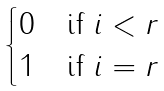<formula> <loc_0><loc_0><loc_500><loc_500>\begin{cases} 0 \quad \text {if } i < r \\ 1 \quad \text {if } i = r \end{cases}</formula> 